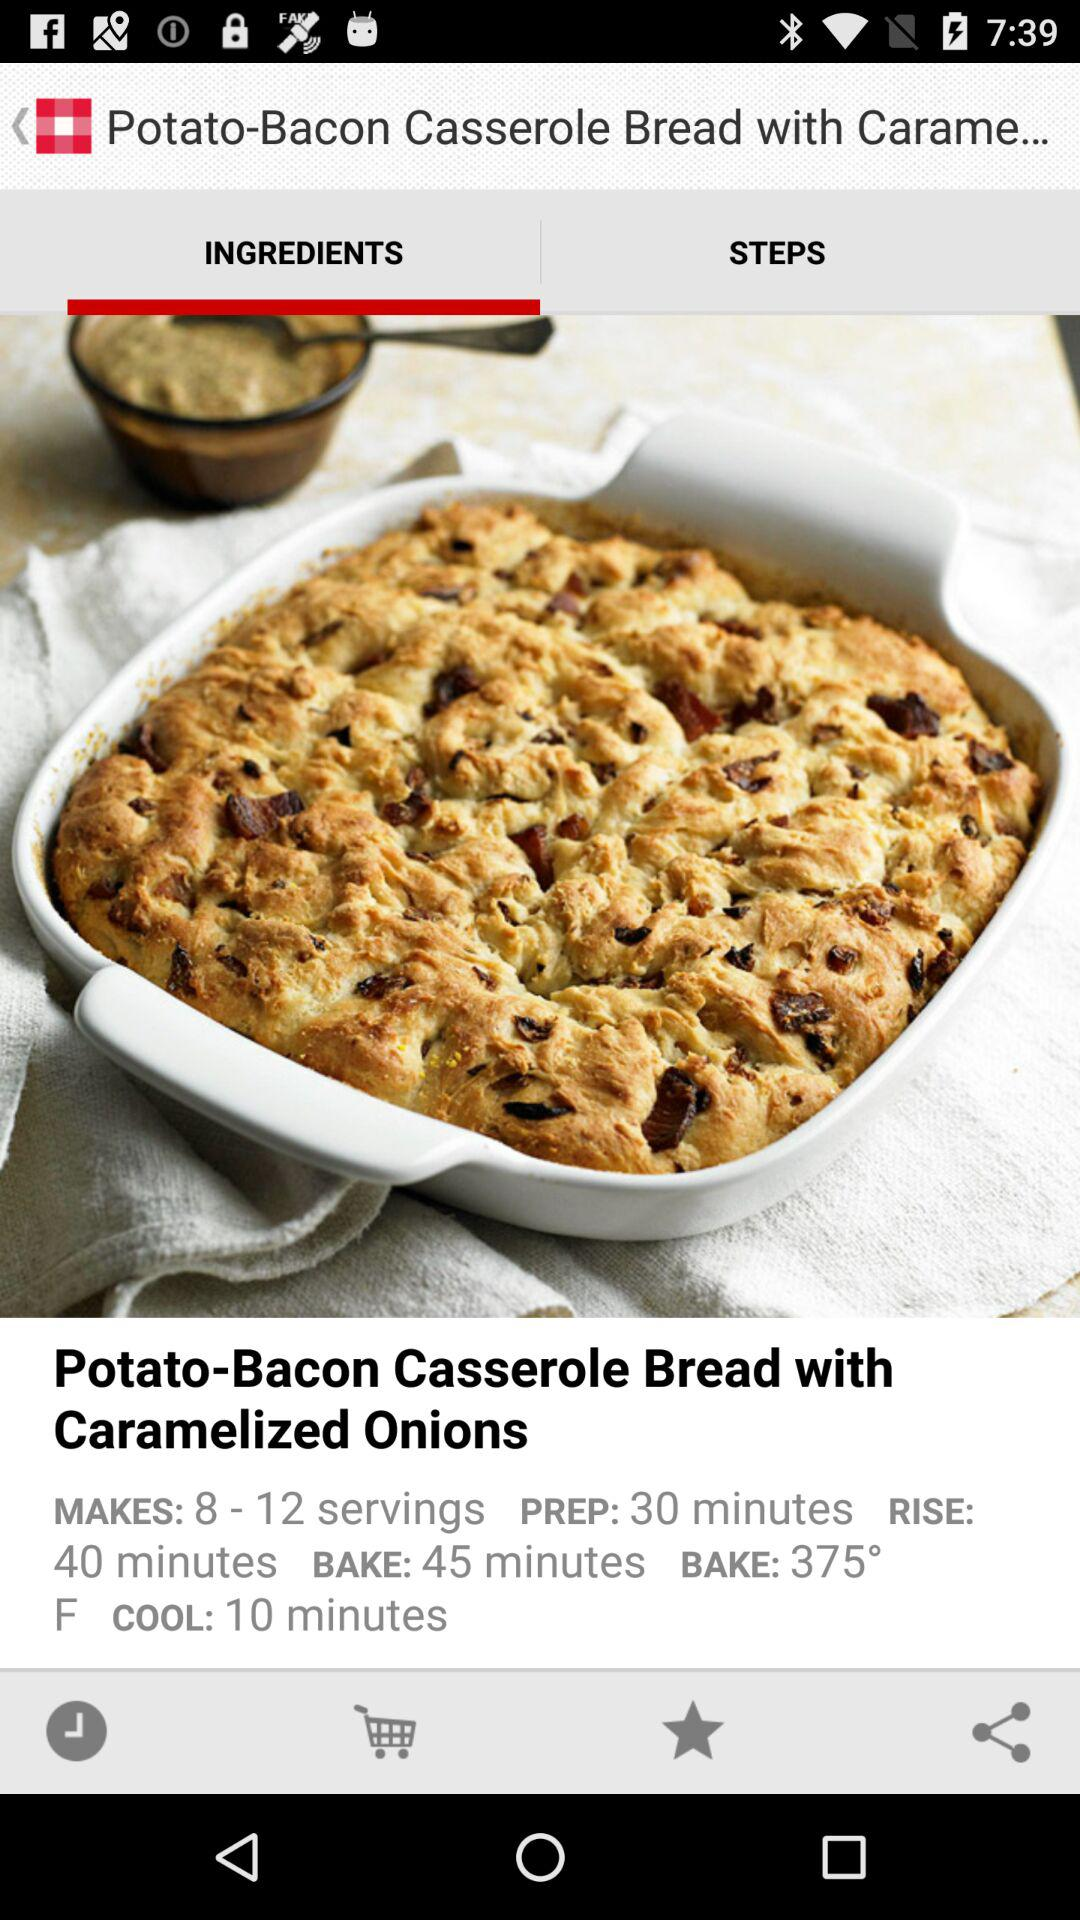What is the cooling time? The cooling time is 10 minutes. 